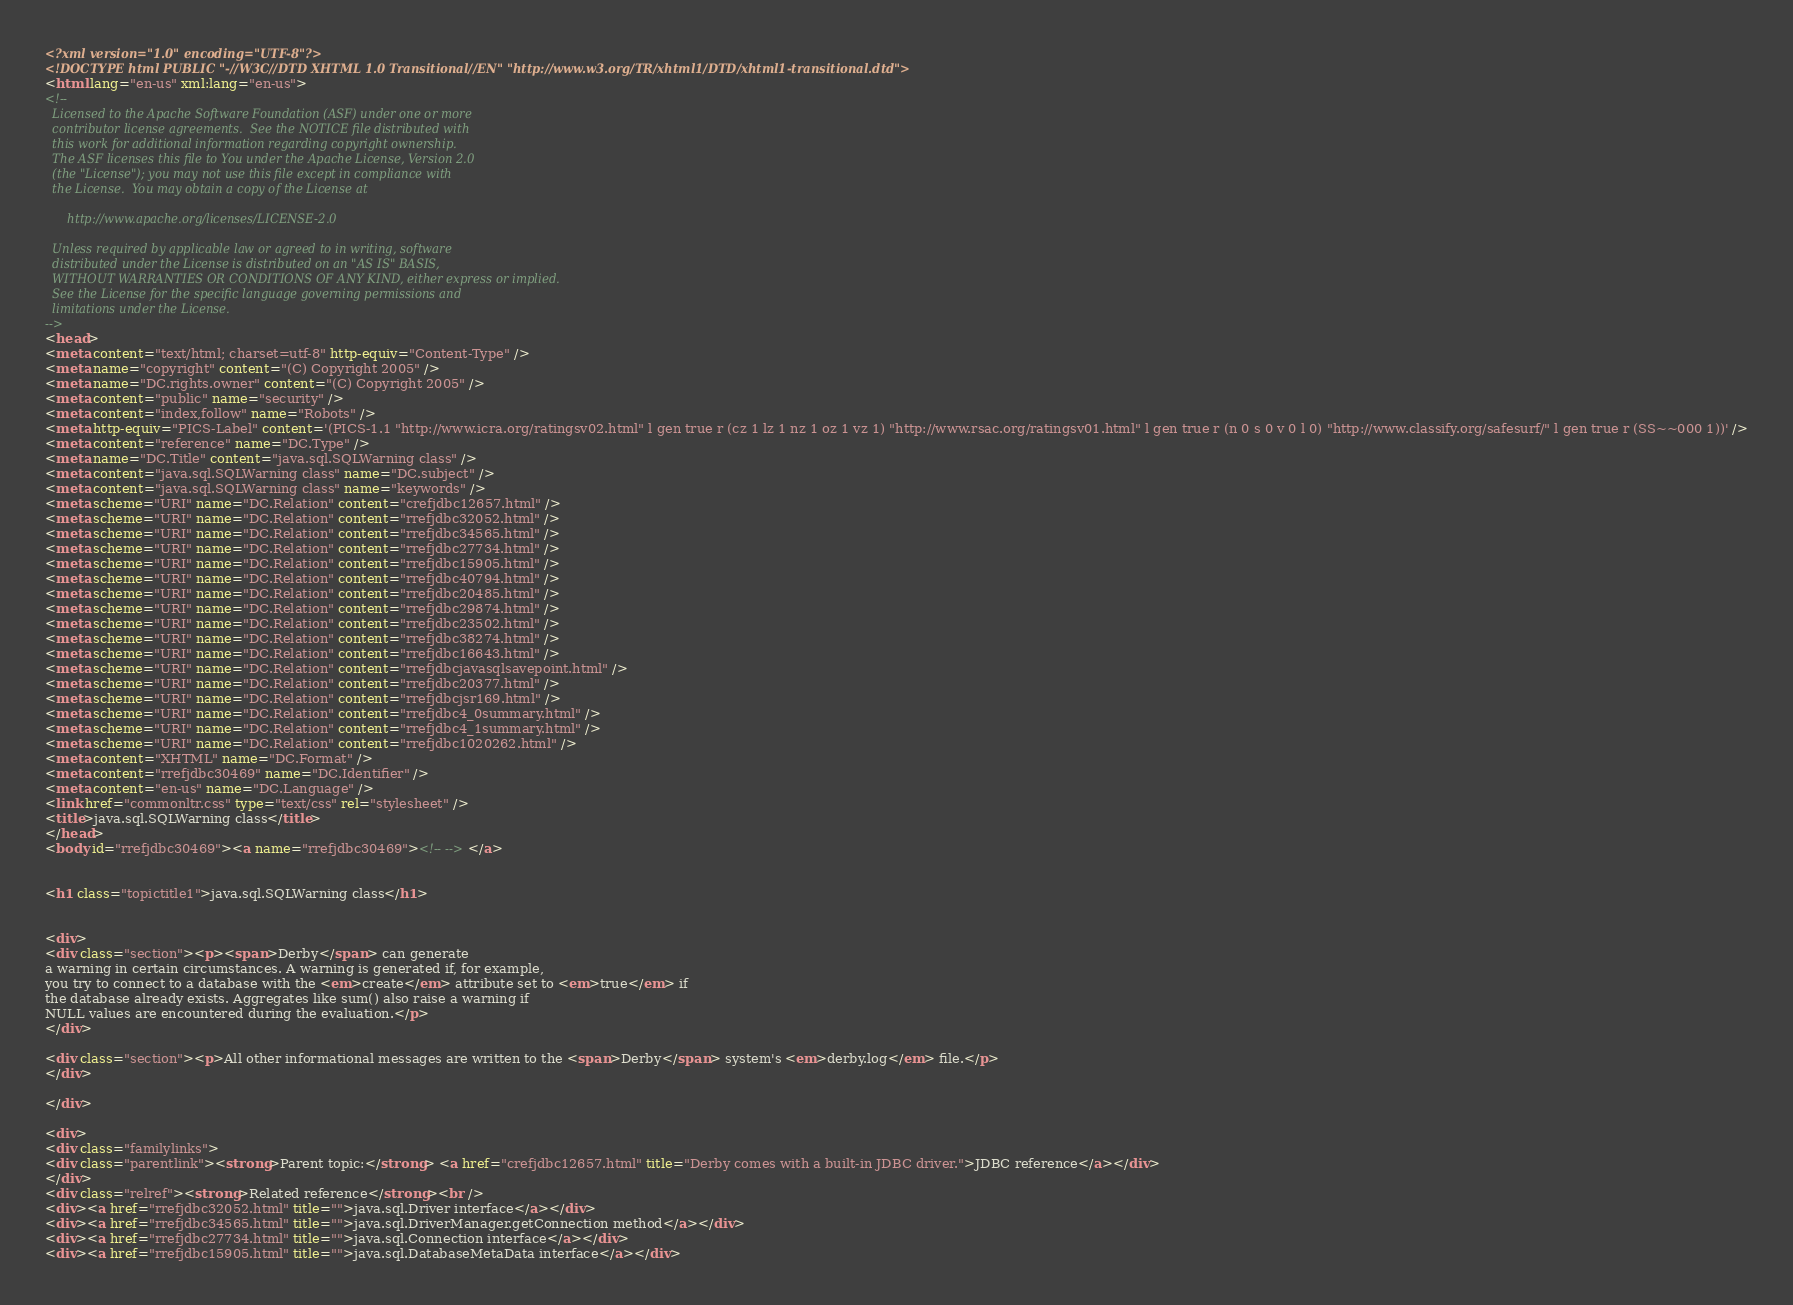<code> <loc_0><loc_0><loc_500><loc_500><_HTML_><?xml version="1.0" encoding="UTF-8"?>
<!DOCTYPE html PUBLIC "-//W3C//DTD XHTML 1.0 Transitional//EN" "http://www.w3.org/TR/xhtml1/DTD/xhtml1-transitional.dtd">
<html lang="en-us" xml:lang="en-us">
<!--
  Licensed to the Apache Software Foundation (ASF) under one or more
  contributor license agreements.  See the NOTICE file distributed with
  this work for additional information regarding copyright ownership.
  The ASF licenses this file to You under the Apache License, Version 2.0
  (the "License"); you may not use this file except in compliance with
  the License.  You may obtain a copy of the License at

      http://www.apache.org/licenses/LICENSE-2.0

  Unless required by applicable law or agreed to in writing, software
  distributed under the License is distributed on an "AS IS" BASIS,
  WITHOUT WARRANTIES OR CONDITIONS OF ANY KIND, either express or implied.
  See the License for the specific language governing permissions and
  limitations under the License.
-->
<head>
<meta content="text/html; charset=utf-8" http-equiv="Content-Type" />
<meta name="copyright" content="(C) Copyright 2005" />
<meta name="DC.rights.owner" content="(C) Copyright 2005" />
<meta content="public" name="security" />
<meta content="index,follow" name="Robots" />
<meta http-equiv="PICS-Label" content='(PICS-1.1 "http://www.icra.org/ratingsv02.html" l gen true r (cz 1 lz 1 nz 1 oz 1 vz 1) "http://www.rsac.org/ratingsv01.html" l gen true r (n 0 s 0 v 0 l 0) "http://www.classify.org/safesurf/" l gen true r (SS~~000 1))' />
<meta content="reference" name="DC.Type" />
<meta name="DC.Title" content="java.sql.SQLWarning class" />
<meta content="java.sql.SQLWarning class" name="DC.subject" />
<meta content="java.sql.SQLWarning class" name="keywords" />
<meta scheme="URI" name="DC.Relation" content="crefjdbc12657.html" />
<meta scheme="URI" name="DC.Relation" content="rrefjdbc32052.html" />
<meta scheme="URI" name="DC.Relation" content="rrefjdbc34565.html" />
<meta scheme="URI" name="DC.Relation" content="rrefjdbc27734.html" />
<meta scheme="URI" name="DC.Relation" content="rrefjdbc15905.html" />
<meta scheme="URI" name="DC.Relation" content="rrefjdbc40794.html" />
<meta scheme="URI" name="DC.Relation" content="rrefjdbc20485.html" />
<meta scheme="URI" name="DC.Relation" content="rrefjdbc29874.html" />
<meta scheme="URI" name="DC.Relation" content="rrefjdbc23502.html" />
<meta scheme="URI" name="DC.Relation" content="rrefjdbc38274.html" />
<meta scheme="URI" name="DC.Relation" content="rrefjdbc16643.html" />
<meta scheme="URI" name="DC.Relation" content="rrefjdbcjavasqlsavepoint.html" />
<meta scheme="URI" name="DC.Relation" content="rrefjdbc20377.html" />
<meta scheme="URI" name="DC.Relation" content="rrefjdbcjsr169.html" />
<meta scheme="URI" name="DC.Relation" content="rrefjdbc4_0summary.html" />
<meta scheme="URI" name="DC.Relation" content="rrefjdbc4_1summary.html" />
<meta scheme="URI" name="DC.Relation" content="rrefjdbc1020262.html" />
<meta content="XHTML" name="DC.Format" />
<meta content="rrefjdbc30469" name="DC.Identifier" />
<meta content="en-us" name="DC.Language" />
<link href="commonltr.css" type="text/css" rel="stylesheet" />
<title>java.sql.SQLWarning class</title>
</head>
<body id="rrefjdbc30469"><a name="rrefjdbc30469"><!-- --></a>


<h1 class="topictitle1">java.sql.SQLWarning class</h1>


<div>
<div class="section"><p><span>Derby</span> can generate
a warning in certain circumstances. A warning is generated if, for example,
you try to connect to a database with the <em>create</em> attribute set to <em>true</em> if
the database already exists. Aggregates like sum() also raise a warning if
NULL values are encountered during the evaluation.</p>
</div>

<div class="section"><p>All other informational messages are written to the <span>Derby</span> system's <em>derby.log</em> file.</p>
</div>

</div>

<div>
<div class="familylinks">
<div class="parentlink"><strong>Parent topic:</strong> <a href="crefjdbc12657.html" title="Derby comes with a built-in JDBC driver.">JDBC reference</a></div>
</div>
<div class="relref"><strong>Related reference</strong><br />
<div><a href="rrefjdbc32052.html" title="">java.sql.Driver interface</a></div>
<div><a href="rrefjdbc34565.html" title="">java.sql.DriverManager.getConnection method</a></div>
<div><a href="rrefjdbc27734.html" title="">java.sql.Connection interface</a></div>
<div><a href="rrefjdbc15905.html" title="">java.sql.DatabaseMetaData interface</a></div></code> 